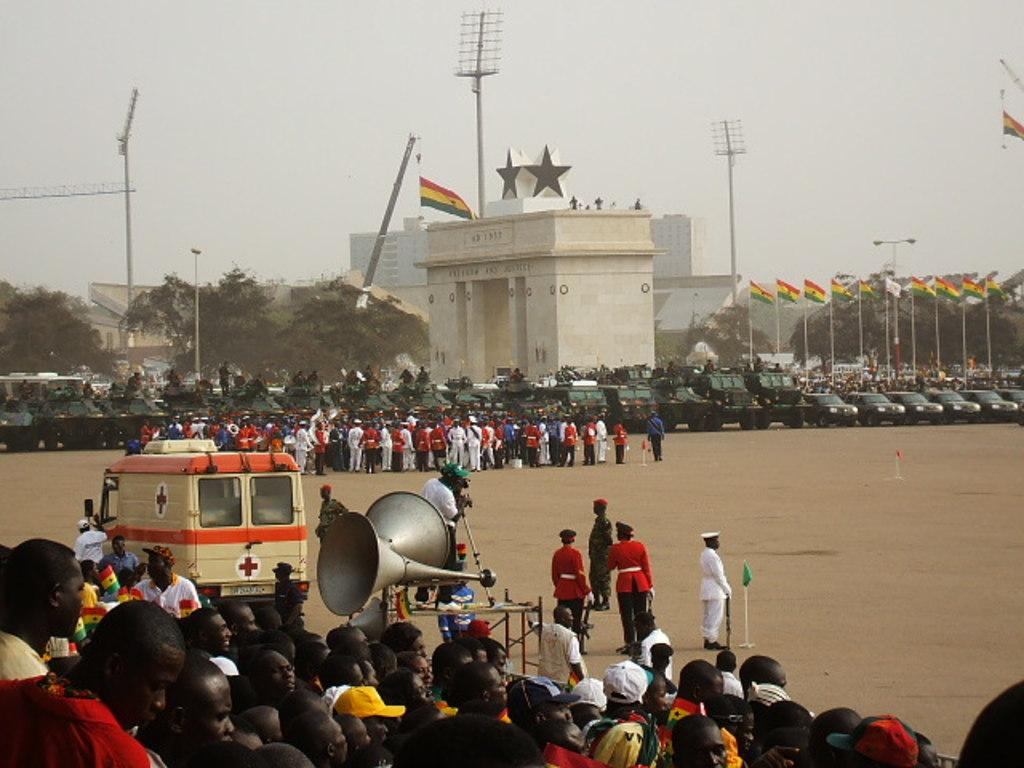What objects with poles can be seen in the image? There are flags with poles in the image. What type of illumination is present in the image? There are lights in the image. What type of transportation is visible in the image? There are vehicles in the image. What type of communication devices are present in the image? There are megaphones in the image. How many people are present in the image? There is a group of people in the image. What type of construction equipment is visible in the image? There are cranes in the image. What type of vegetation is present in the image? There are trees in the image. What type of man-made structures are present in the image? There are buildings in the image. What is visible in the background of the image? The sky is visible in the background of the image. Can you see any ghosts in the image? There are no ghosts present in the image. How many times do the people in the image kick the ball? There is no ball present in the image, so it is not possible to determine how many times the people kick it. 